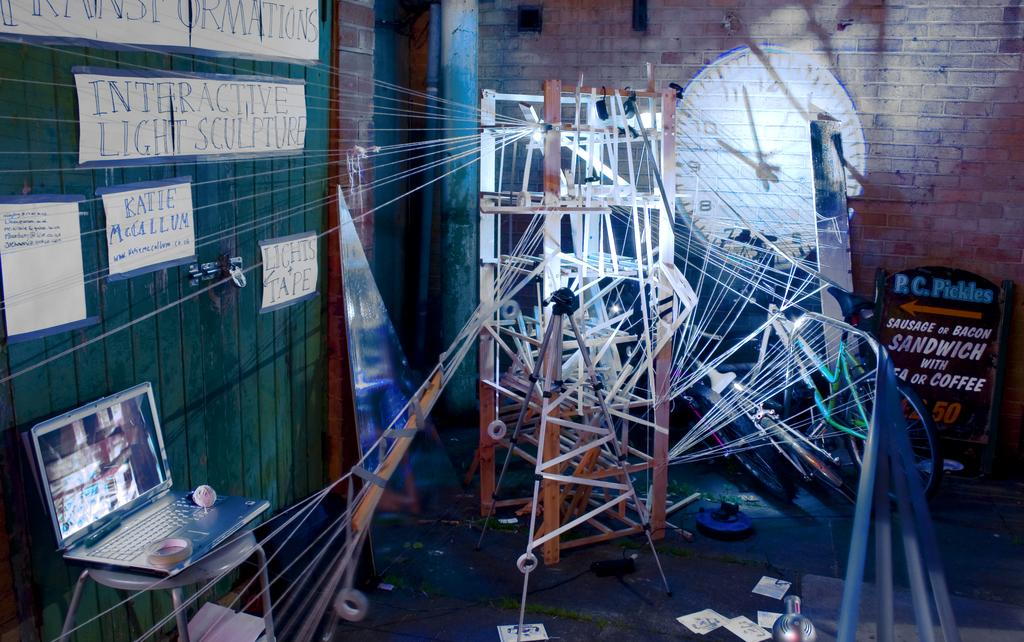<image>
Present a compact description of the photo's key features. An Interactive Light Sculpture is displayed in the corner of a brick room. 